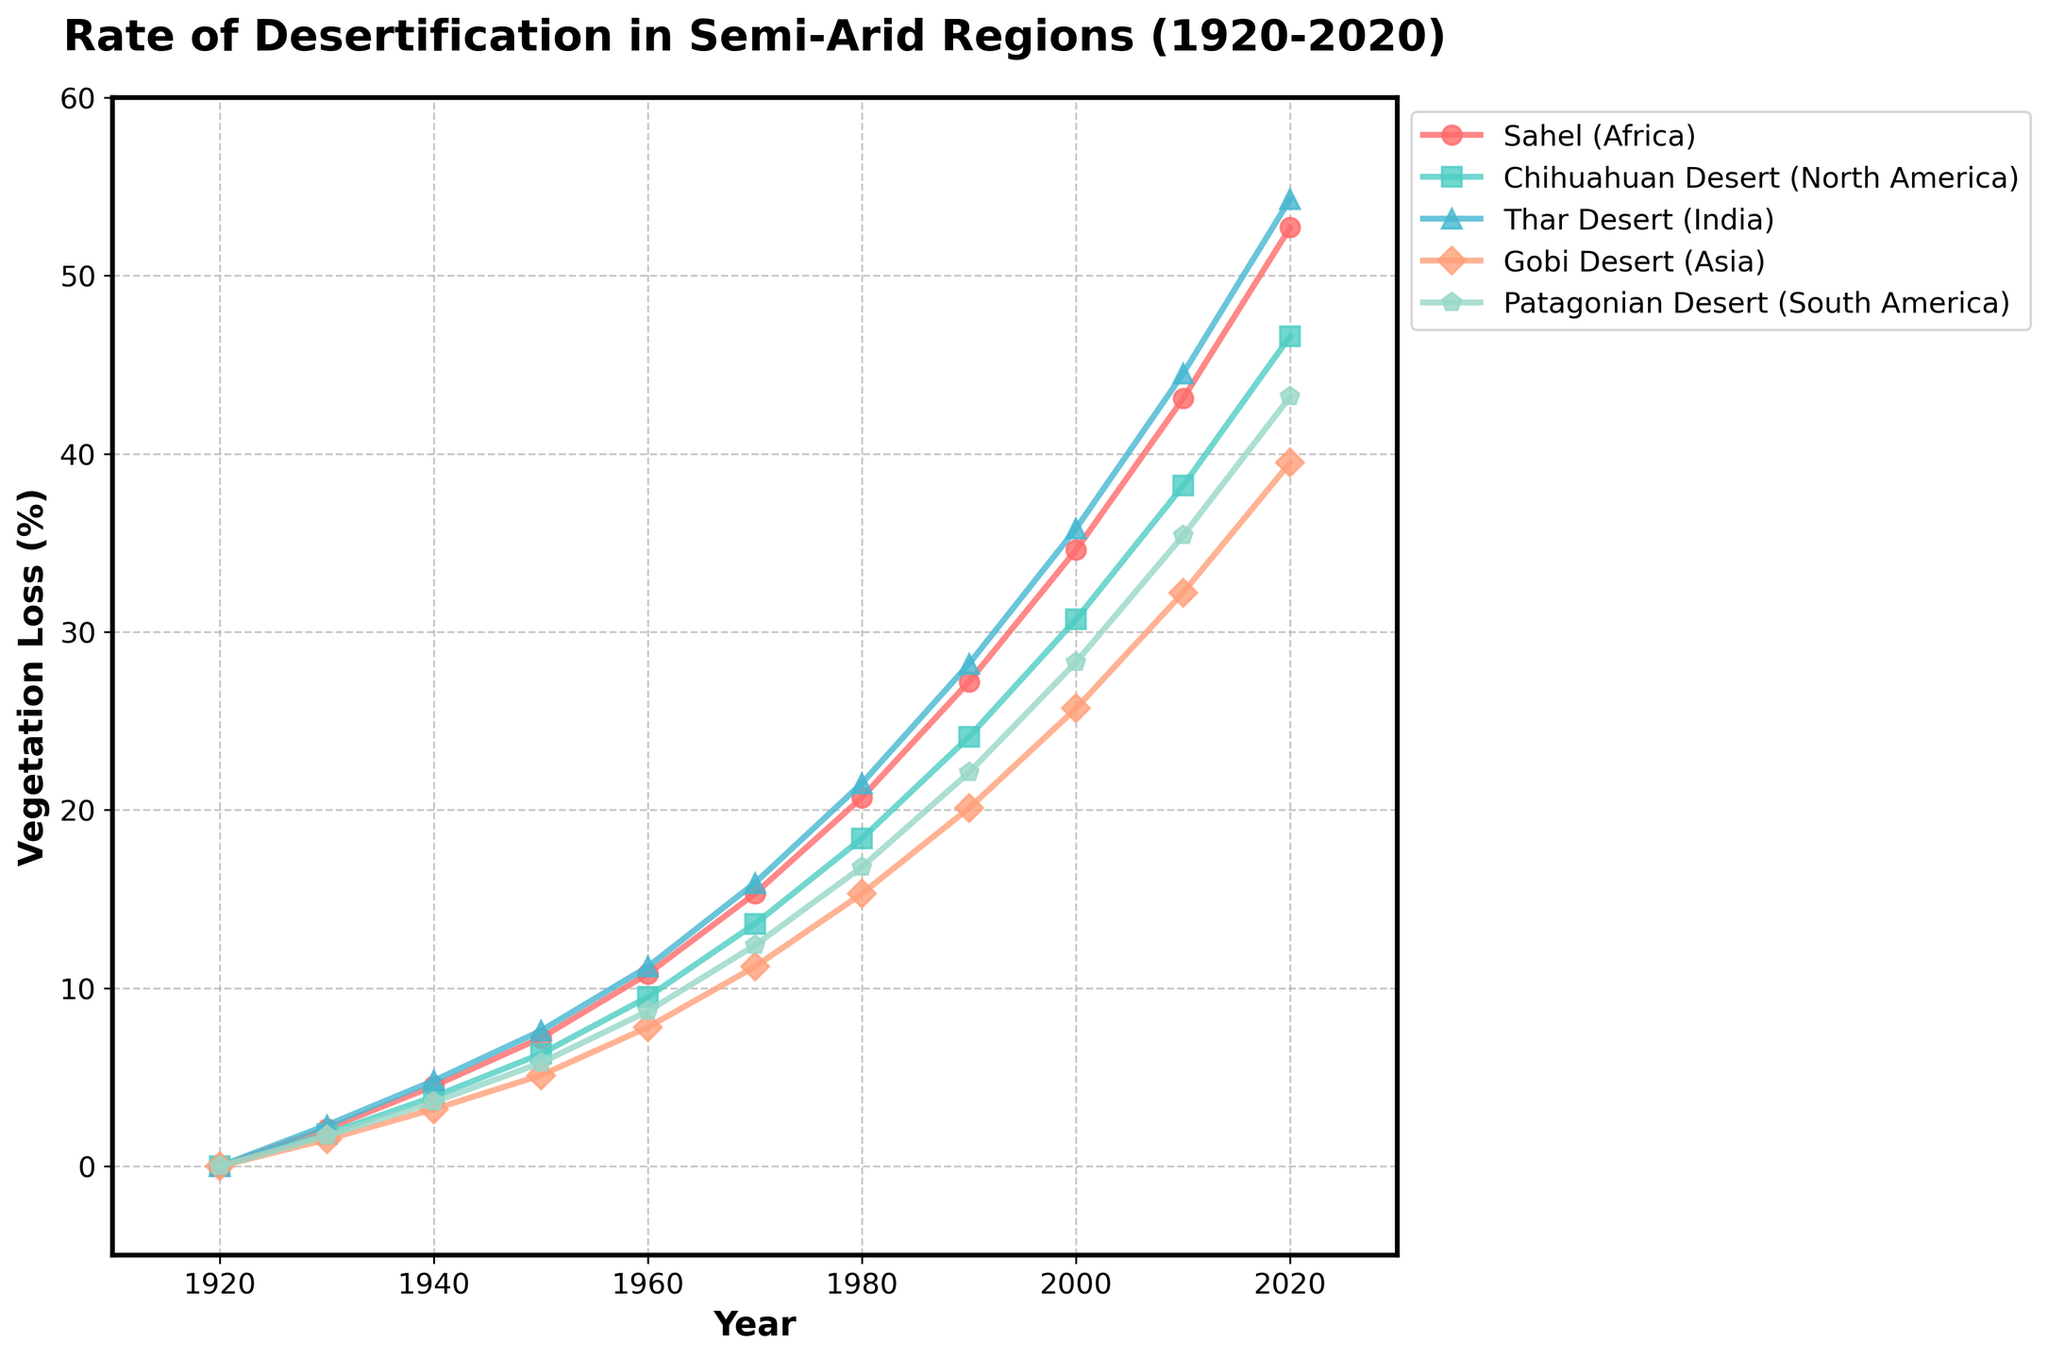What is the general trend of vegetation loss in the Sahel region from 1920 to 2020? The line representing the Sahel region shows a consistent upward trend from 1920 to 2020, indicating increasing vegetation loss over time.
Answer: Increasing Which region had the highest percentage of vegetation loss in 2020? In 2020, the line for the Sahel region reaches the highest point compared to other regions, indicating that the Sahel had the highest percentage of vegetation loss.
Answer: Sahel Between 1950 and 1960, which region experienced the greatest increase in vegetation loss? Comparing the vertical distance between the points for 1950 and 1960 on each line, the Sahel region shows the largest increase. The increase for the Sahel is from 7.2% to 10.8%, which is 3.6 percentage points, higher than any other region.
Answer: Sahel How does vegetation loss in the Gobi Desert in 1970 compare to the Chihuahuan Desert in the same year? In 1970, the vegetation loss for the Gobi Desert is 11.2%, and for the Chihuahuan Desert, it is 13.6%. The Chihuahuan Desert has a higher vegetation loss.
Answer: The Chihuahuan Desert has higher vegetation loss Calculate the average rate of vegetation loss for the Patagonian Desert over the full time period. Summing up the Patagonian Desert values from 1920 to 2020: (0 + 1.7 + 3.6 + 5.8 + 8.7 + 12.4 + 16.8 + 22.1 + 28.3 + 35.4 + 43.2 = 178). There are 11 time points, so the average rate is 178 / 11 = 16.18%.
Answer: 16.18% Which region first reached a vegetation loss of more than 20%? By examining when each line crosses the 20% mark, the Sahel region first exceeds 20% in 1980.
Answer: Sahel What is the percentage difference in vegetation loss between the Thar Desert and the Chihuahuan Desert in 1990? In 1990, the Thar Desert had a 28.2% vegetation loss, and the Chihuahuan Desert had a 24.1% loss. The difference is 28.2% - 24.1% = 4.1%.
Answer: 4.1% Which region shows the most rapid increase in vegetation loss between 2000 and 2010? By comparing the slopes of the lines between 2000 and 2010, the Sahel region shows the steepest slope, meaning it had the most rapid increase. The increase for the Sahel is from 34.6% to 43.1%, a 8.5 percentage point increase, which is the largest among the regions.
Answer: Sahel 